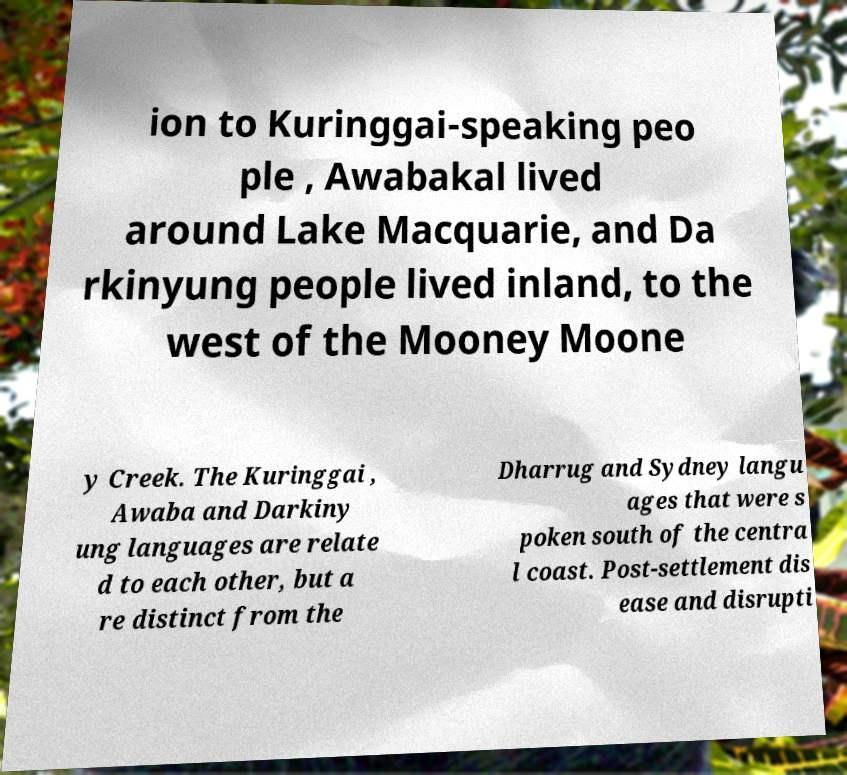I need the written content from this picture converted into text. Can you do that? ion to Kuringgai-speaking peo ple , Awabakal lived around Lake Macquarie, and Da rkinyung people lived inland, to the west of the Mooney Moone y Creek. The Kuringgai , Awaba and Darkiny ung languages are relate d to each other, but a re distinct from the Dharrug and Sydney langu ages that were s poken south of the centra l coast. Post-settlement dis ease and disrupti 